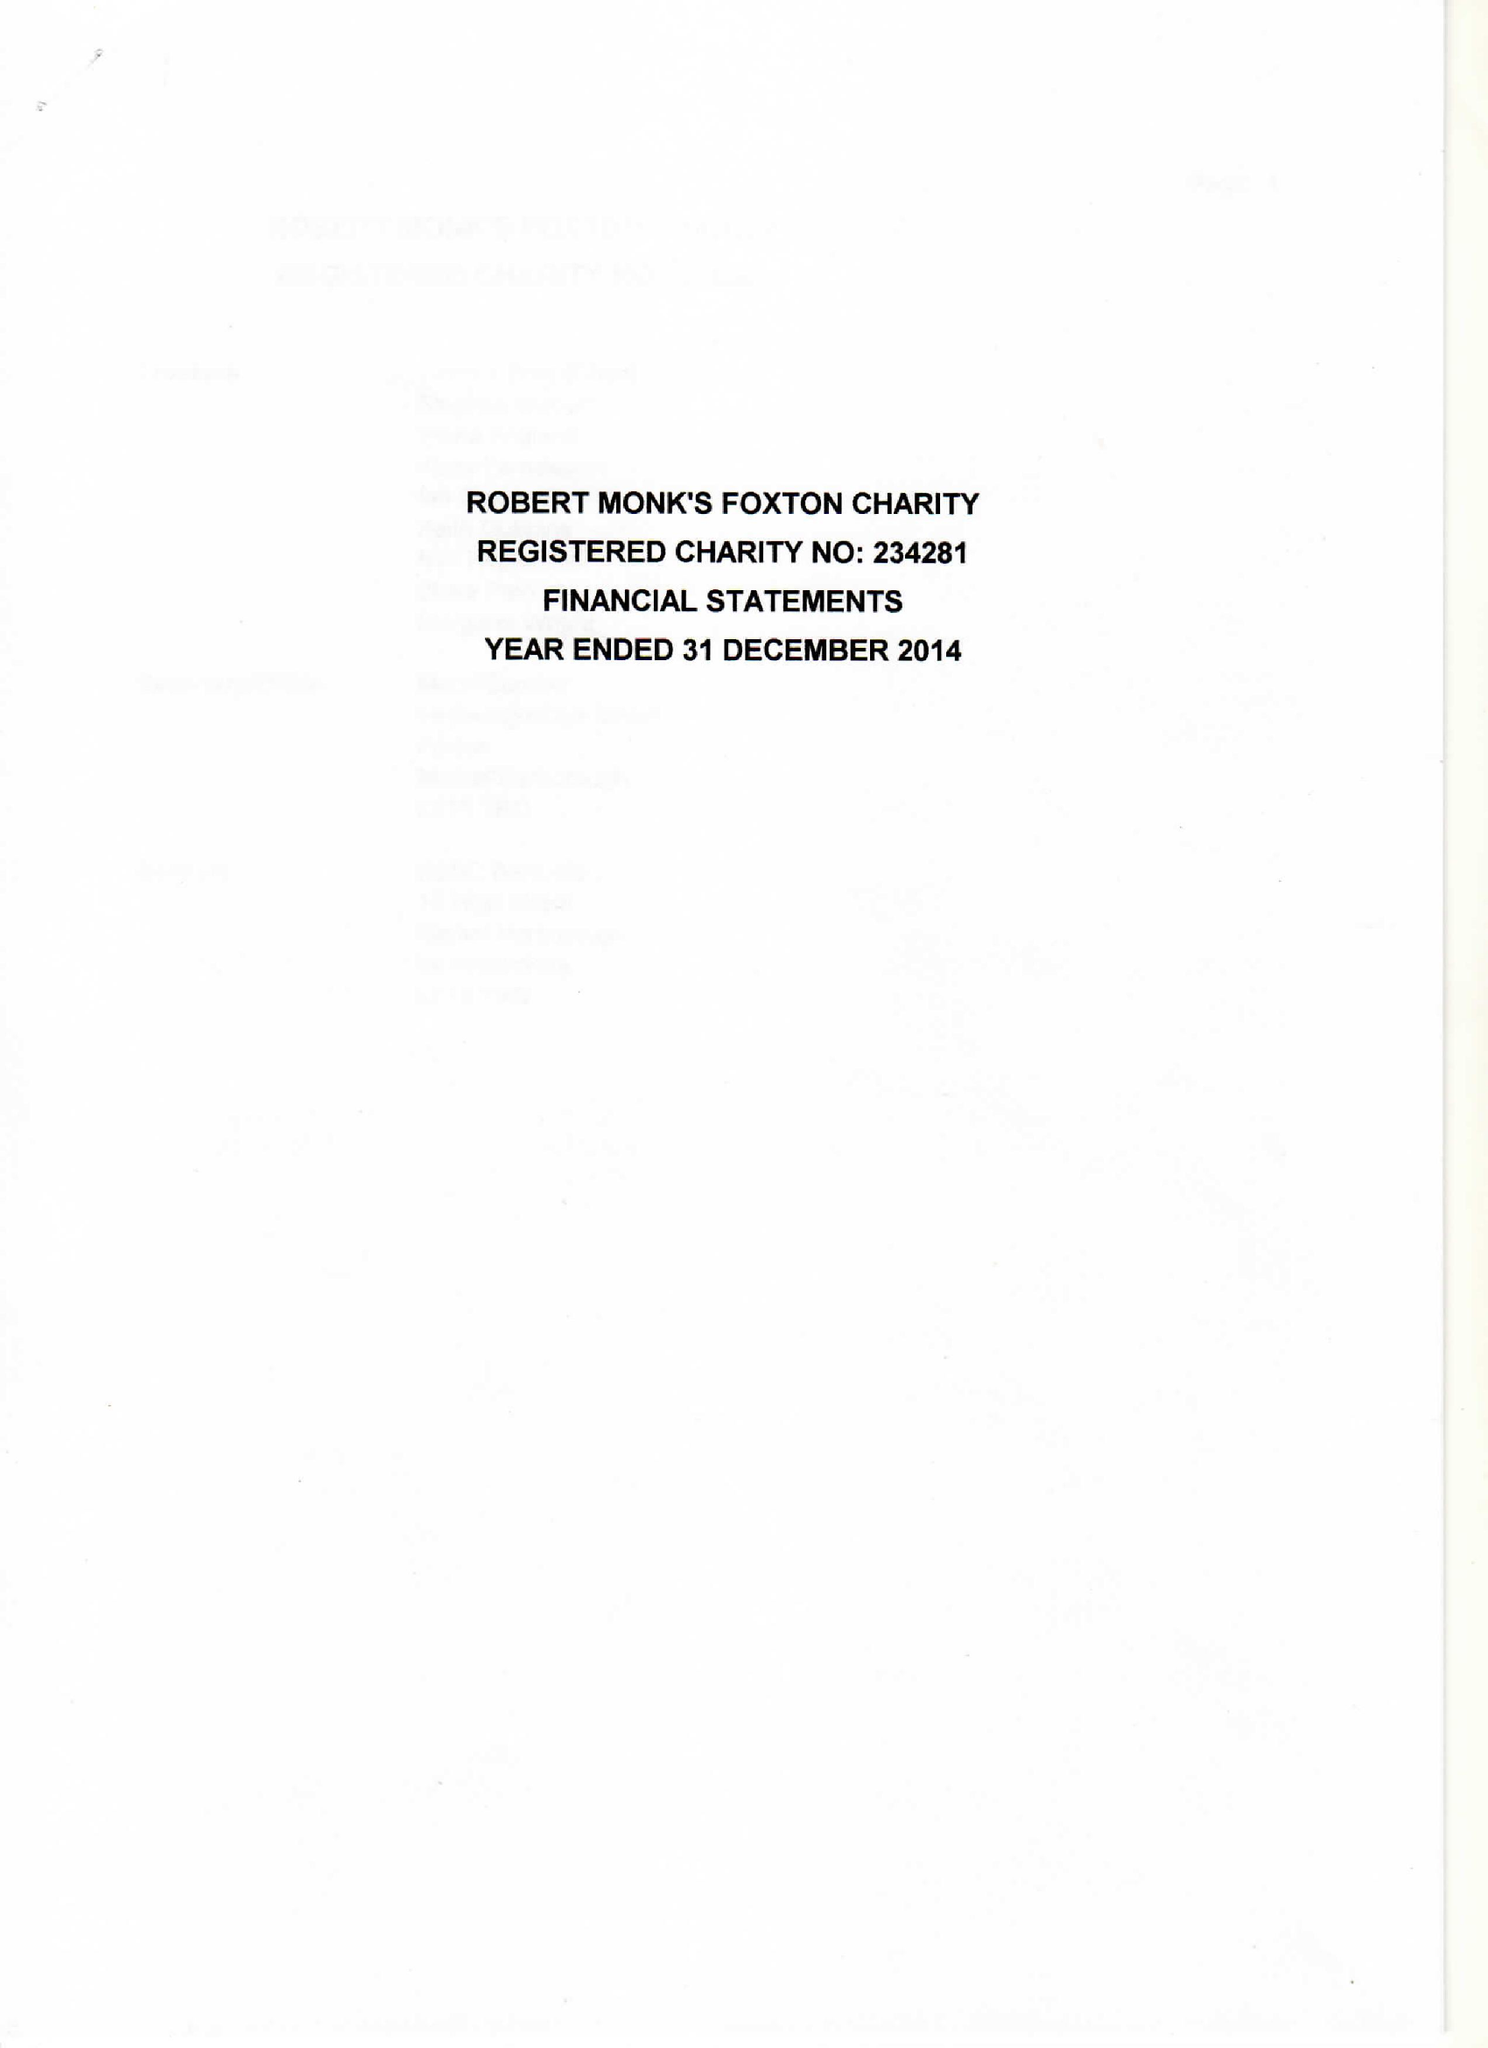What is the value for the address__postcode?
Answer the question using a single word or phrase. LE16 7RE 